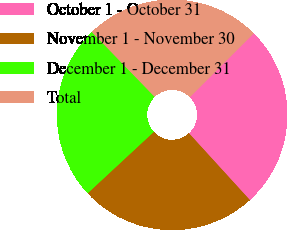Convert chart. <chart><loc_0><loc_0><loc_500><loc_500><pie_chart><fcel>October 1 - October 31<fcel>November 1 - November 30<fcel>December 1 - December 31<fcel>Total<nl><fcel>25.72%<fcel>24.86%<fcel>24.65%<fcel>24.76%<nl></chart> 